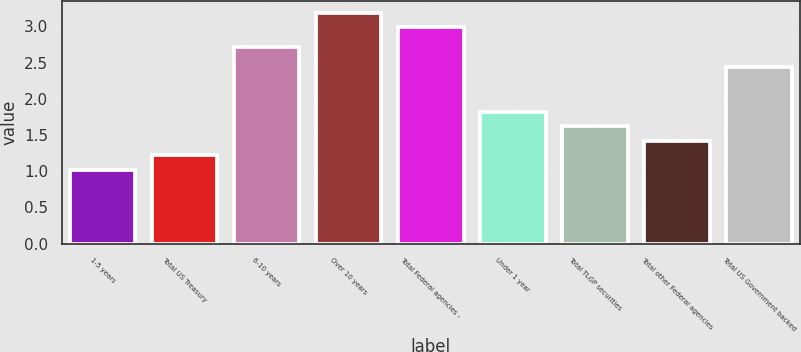<chart> <loc_0><loc_0><loc_500><loc_500><bar_chart><fcel>1-5 years<fcel>Total US Treasury<fcel>6-10 years<fcel>Over 10 years<fcel>Total Federal agencies -<fcel>Under 1 year<fcel>Total TLGP securities<fcel>Total other Federal agencies<fcel>Total US Government backed<nl><fcel>1.02<fcel>1.22<fcel>2.72<fcel>3.19<fcel>2.99<fcel>1.82<fcel>1.62<fcel>1.42<fcel>2.44<nl></chart> 